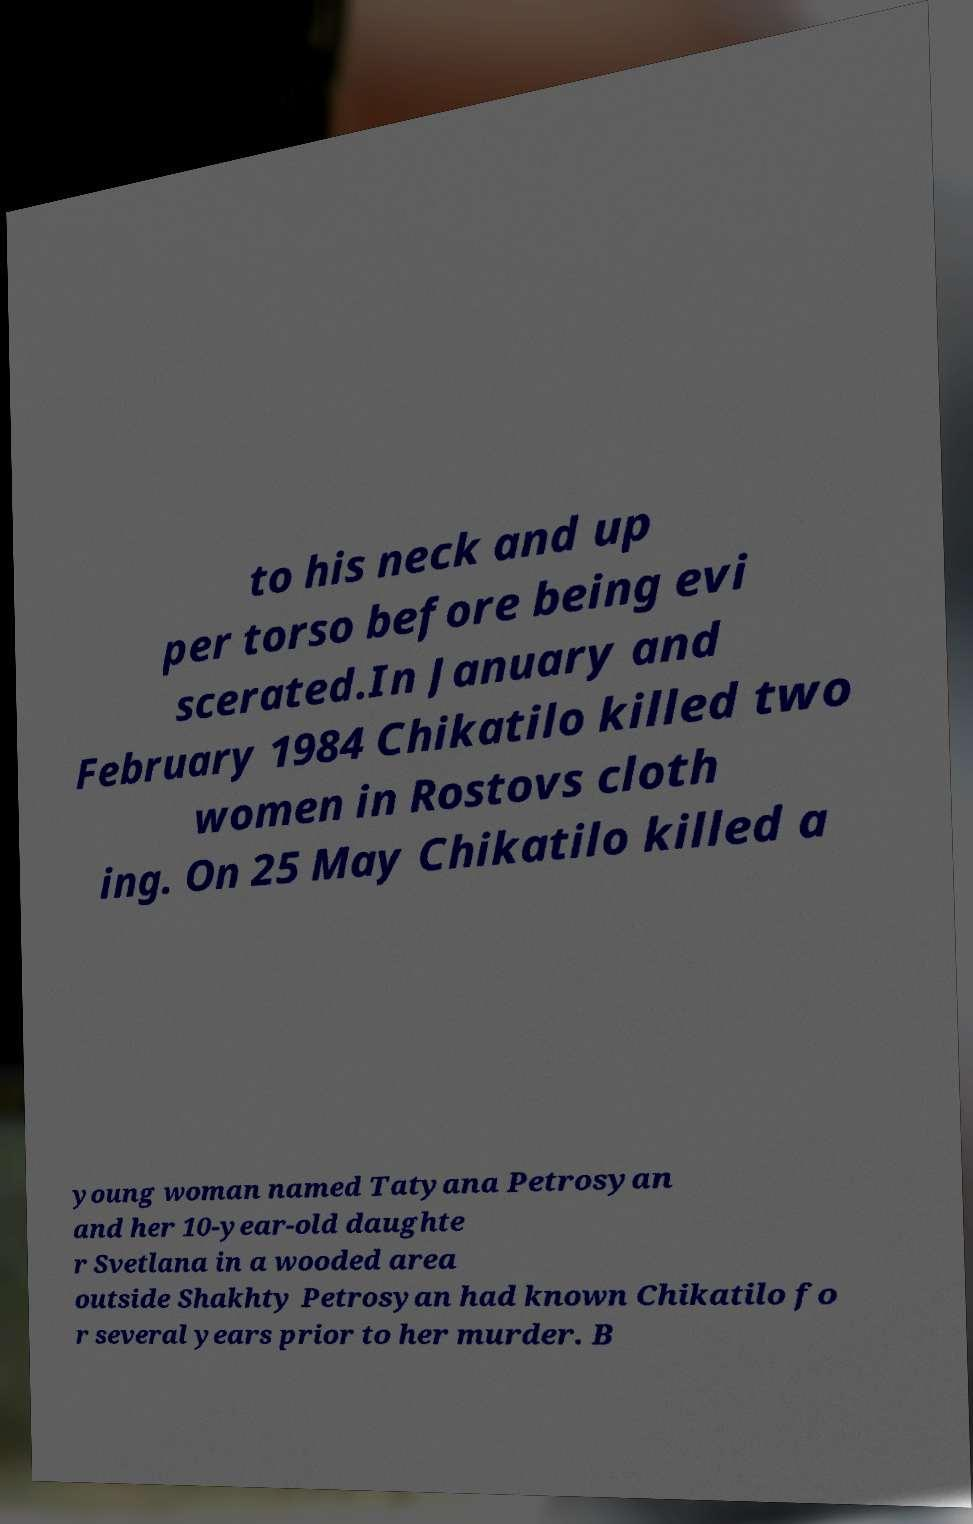Please read and relay the text visible in this image. What does it say? to his neck and up per torso before being evi scerated.In January and February 1984 Chikatilo killed two women in Rostovs cloth ing. On 25 May Chikatilo killed a young woman named Tatyana Petrosyan and her 10-year-old daughte r Svetlana in a wooded area outside Shakhty Petrosyan had known Chikatilo fo r several years prior to her murder. B 